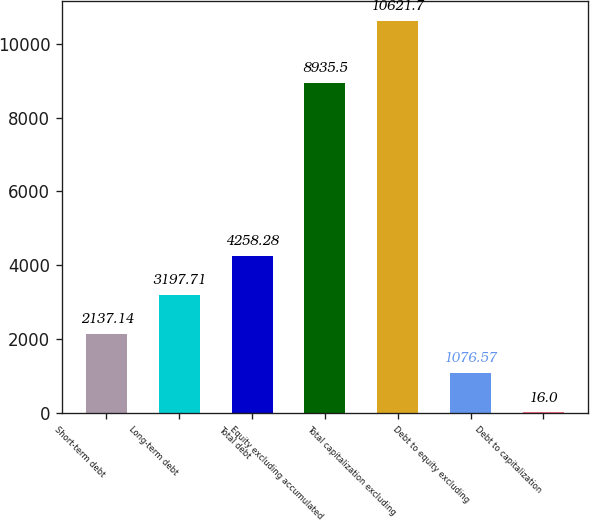<chart> <loc_0><loc_0><loc_500><loc_500><bar_chart><fcel>Short-term debt<fcel>Long-term debt<fcel>Total debt<fcel>Equity excluding accumulated<fcel>Total capitalization excluding<fcel>Debt to equity excluding<fcel>Debt to capitalization<nl><fcel>2137.14<fcel>3197.71<fcel>4258.28<fcel>8935.5<fcel>10621.7<fcel>1076.57<fcel>16<nl></chart> 